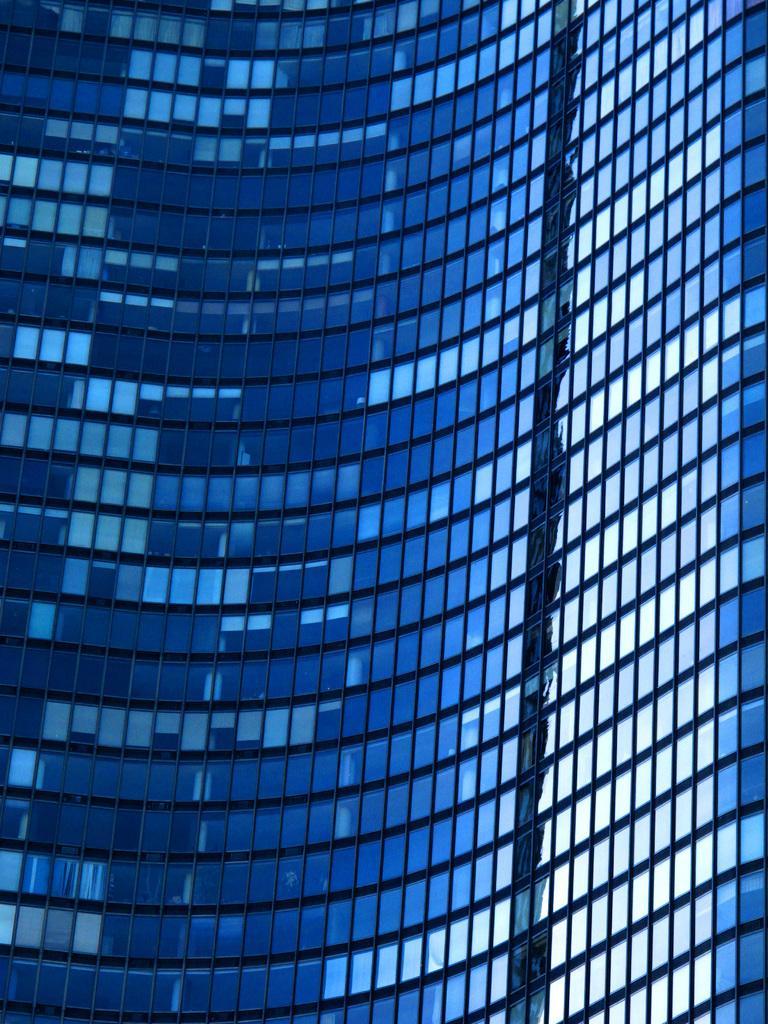Could you give a brief overview of what you see in this image? This is a picture of a building with glass doors. 